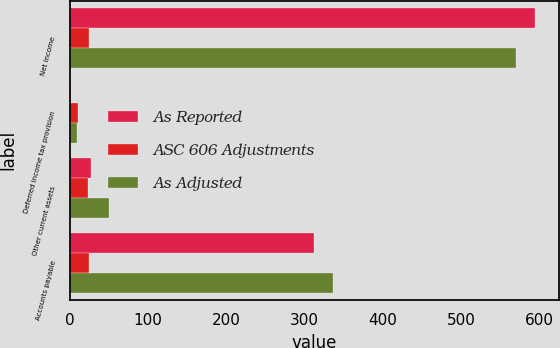Convert chart. <chart><loc_0><loc_0><loc_500><loc_500><stacked_bar_chart><ecel><fcel>Net income<fcel>Deferred income tax provision<fcel>Other current assets<fcel>Accounts payable<nl><fcel>As Reported<fcel>595<fcel>1.1<fcel>27.4<fcel>311.9<nl><fcel>ASC 606 Adjustments<fcel>24.6<fcel>10.6<fcel>22.7<fcel>24.5<nl><fcel>As Adjusted<fcel>570.4<fcel>9.5<fcel>50.1<fcel>336.4<nl></chart> 